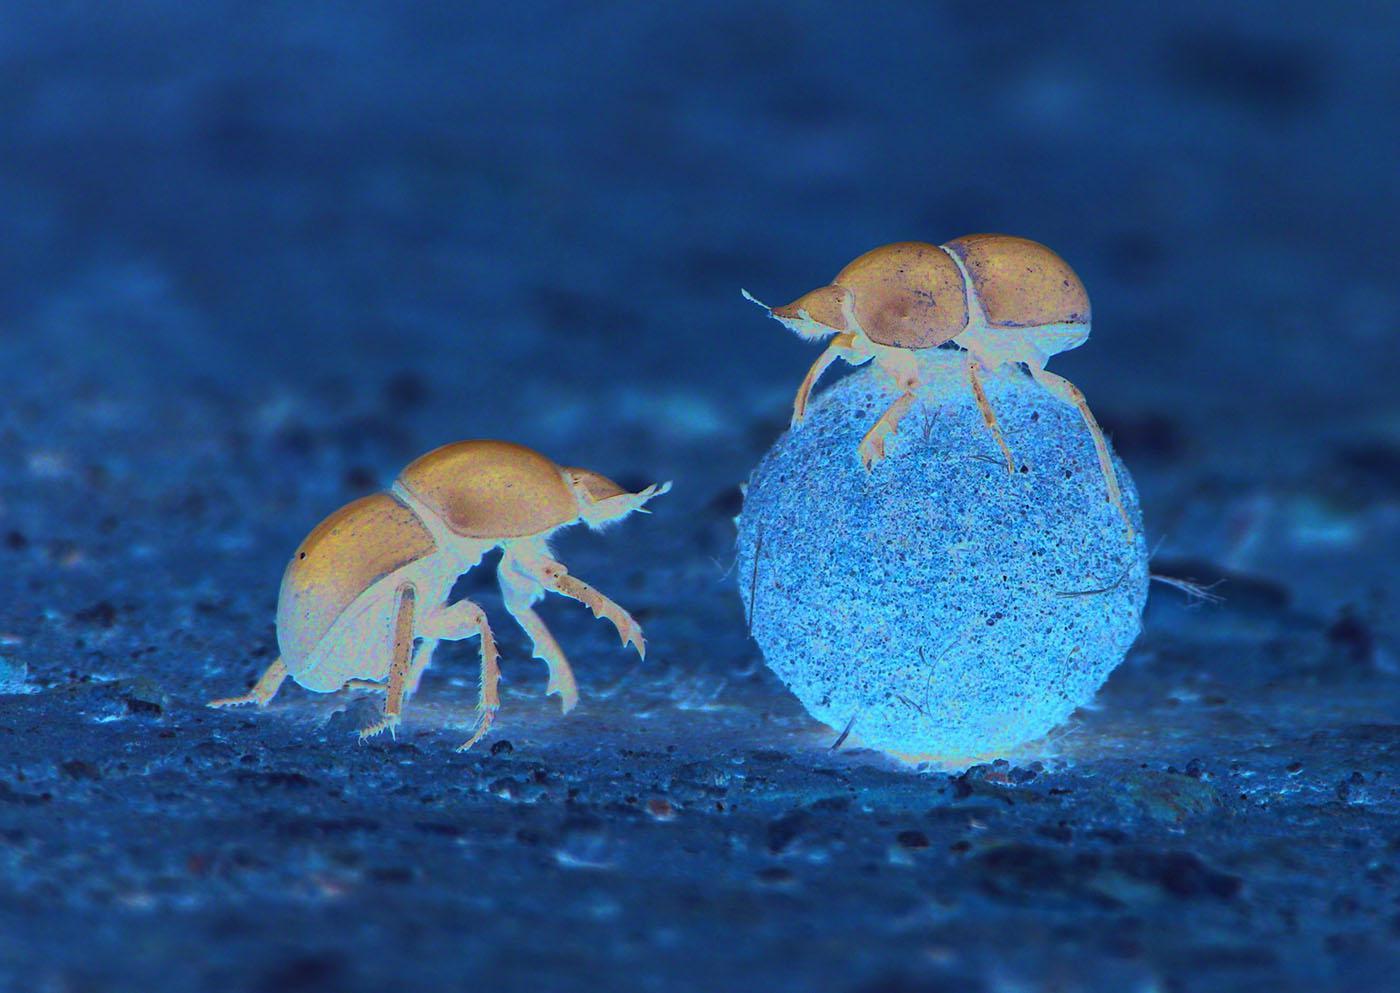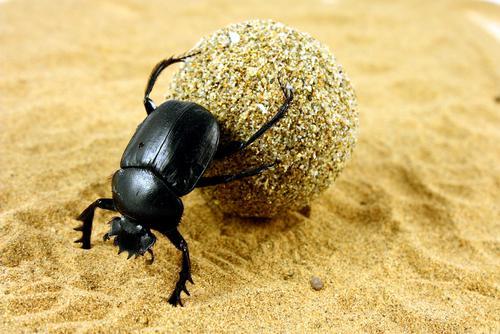The first image is the image on the left, the second image is the image on the right. Given the left and right images, does the statement "there are two insects in the image on the left." hold true? Answer yes or no. Yes. The first image is the image on the left, the second image is the image on the right. Analyze the images presented: Is the assertion "In one image, one beetle is on the ground next to a beetle on a dung ball." valid? Answer yes or no. Yes. The first image is the image on the left, the second image is the image on the right. Evaluate the accuracy of this statement regarding the images: "The image on the left contains two insects.". Is it true? Answer yes or no. Yes. 